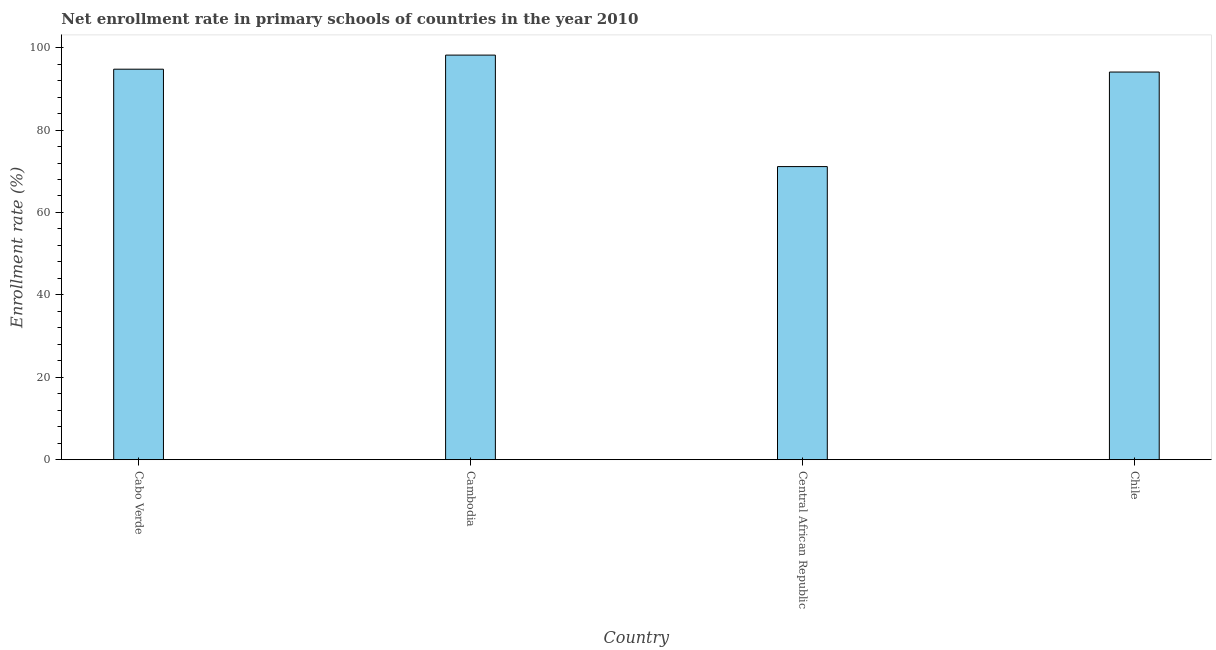Does the graph contain any zero values?
Your answer should be compact. No. Does the graph contain grids?
Keep it short and to the point. No. What is the title of the graph?
Your answer should be compact. Net enrollment rate in primary schools of countries in the year 2010. What is the label or title of the Y-axis?
Keep it short and to the point. Enrollment rate (%). What is the net enrollment rate in primary schools in Cambodia?
Your answer should be very brief. 98.19. Across all countries, what is the maximum net enrollment rate in primary schools?
Provide a short and direct response. 98.19. Across all countries, what is the minimum net enrollment rate in primary schools?
Your answer should be compact. 71.14. In which country was the net enrollment rate in primary schools maximum?
Provide a short and direct response. Cambodia. In which country was the net enrollment rate in primary schools minimum?
Keep it short and to the point. Central African Republic. What is the sum of the net enrollment rate in primary schools?
Offer a very short reply. 358.19. What is the difference between the net enrollment rate in primary schools in Central African Republic and Chile?
Your response must be concise. -22.95. What is the average net enrollment rate in primary schools per country?
Your answer should be compact. 89.55. What is the median net enrollment rate in primary schools?
Offer a terse response. 94.43. In how many countries, is the net enrollment rate in primary schools greater than 40 %?
Your answer should be very brief. 4. What is the ratio of the net enrollment rate in primary schools in Central African Republic to that in Chile?
Your response must be concise. 0.76. Is the net enrollment rate in primary schools in Cambodia less than that in Chile?
Your answer should be very brief. No. What is the difference between the highest and the second highest net enrollment rate in primary schools?
Give a very brief answer. 3.42. What is the difference between the highest and the lowest net enrollment rate in primary schools?
Ensure brevity in your answer.  27.06. Are all the bars in the graph horizontal?
Provide a succinct answer. No. How many countries are there in the graph?
Your response must be concise. 4. What is the difference between two consecutive major ticks on the Y-axis?
Make the answer very short. 20. What is the Enrollment rate (%) of Cabo Verde?
Your response must be concise. 94.77. What is the Enrollment rate (%) of Cambodia?
Your response must be concise. 98.19. What is the Enrollment rate (%) of Central African Republic?
Your answer should be very brief. 71.14. What is the Enrollment rate (%) in Chile?
Offer a terse response. 94.08. What is the difference between the Enrollment rate (%) in Cabo Verde and Cambodia?
Offer a terse response. -3.42. What is the difference between the Enrollment rate (%) in Cabo Verde and Central African Republic?
Give a very brief answer. 23.64. What is the difference between the Enrollment rate (%) in Cabo Verde and Chile?
Your response must be concise. 0.69. What is the difference between the Enrollment rate (%) in Cambodia and Central African Republic?
Your answer should be very brief. 27.06. What is the difference between the Enrollment rate (%) in Cambodia and Chile?
Keep it short and to the point. 4.11. What is the difference between the Enrollment rate (%) in Central African Republic and Chile?
Keep it short and to the point. -22.95. What is the ratio of the Enrollment rate (%) in Cabo Verde to that in Central African Republic?
Provide a short and direct response. 1.33. What is the ratio of the Enrollment rate (%) in Cabo Verde to that in Chile?
Keep it short and to the point. 1.01. What is the ratio of the Enrollment rate (%) in Cambodia to that in Central African Republic?
Provide a succinct answer. 1.38. What is the ratio of the Enrollment rate (%) in Cambodia to that in Chile?
Ensure brevity in your answer.  1.04. What is the ratio of the Enrollment rate (%) in Central African Republic to that in Chile?
Provide a short and direct response. 0.76. 